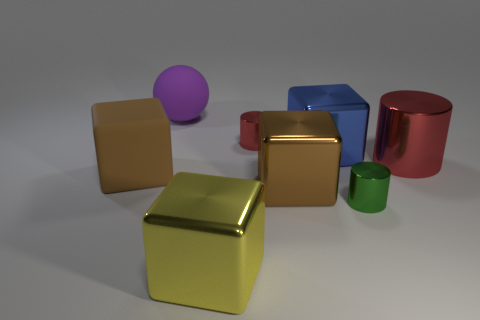Subtract 2 cubes. How many cubes are left? 2 Add 1 tiny red shiny things. How many objects exist? 9 Subtract all red cubes. Subtract all brown cylinders. How many cubes are left? 4 Subtract 0 brown balls. How many objects are left? 8 Subtract all cylinders. How many objects are left? 5 Subtract all big brown metal blocks. Subtract all small red cylinders. How many objects are left? 6 Add 2 yellow objects. How many yellow objects are left? 3 Add 5 tiny brown metal objects. How many tiny brown metal objects exist? 5 